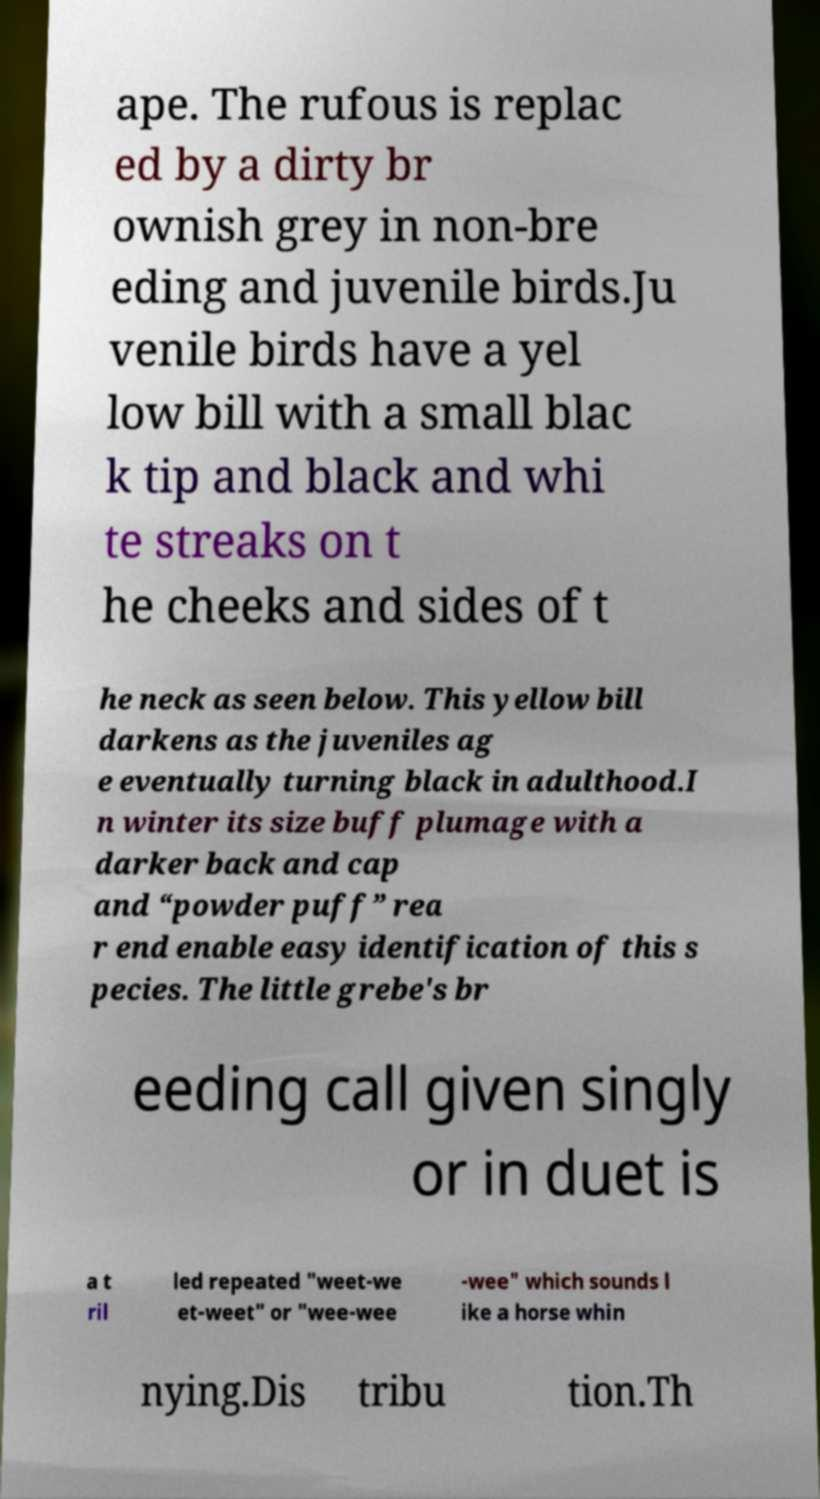Could you extract and type out the text from this image? ape. The rufous is replac ed by a dirty br ownish grey in non-bre eding and juvenile birds.Ju venile birds have a yel low bill with a small blac k tip and black and whi te streaks on t he cheeks and sides of t he neck as seen below. This yellow bill darkens as the juveniles ag e eventually turning black in adulthood.I n winter its size buff plumage with a darker back and cap and “powder puff” rea r end enable easy identification of this s pecies. The little grebe's br eeding call given singly or in duet is a t ril led repeated "weet-we et-weet" or "wee-wee -wee" which sounds l ike a horse whin nying.Dis tribu tion.Th 